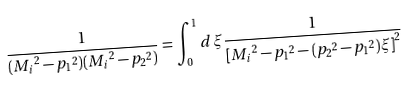Convert formula to latex. <formula><loc_0><loc_0><loc_500><loc_500>\frac { 1 } { ( { M _ { i } } ^ { 2 } - { p _ { 1 } } ^ { 2 } ) ( { M _ { i } } ^ { 2 } - { p _ { 2 } } ^ { 2 } ) } = \int _ { 0 } ^ { 1 } d \, \xi \frac { 1 } { { [ { M _ { i } } ^ { 2 } - { p _ { 1 } } ^ { 2 } - ( { p _ { 2 } } ^ { 2 } - { p _ { 1 } } ^ { 2 } ) \xi ] } ^ { 2 } }</formula> 